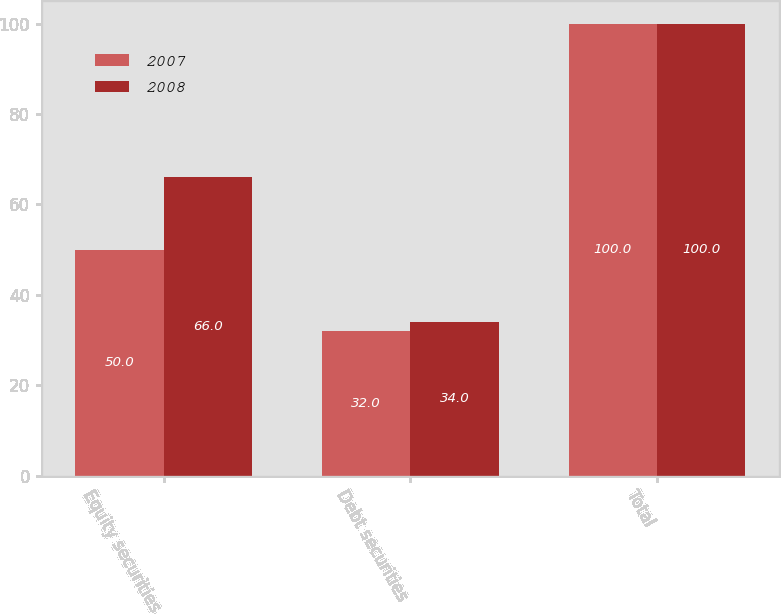Convert chart to OTSL. <chart><loc_0><loc_0><loc_500><loc_500><stacked_bar_chart><ecel><fcel>Equity securities<fcel>Debt securities<fcel>Total<nl><fcel>2007<fcel>50<fcel>32<fcel>100<nl><fcel>2008<fcel>66<fcel>34<fcel>100<nl></chart> 